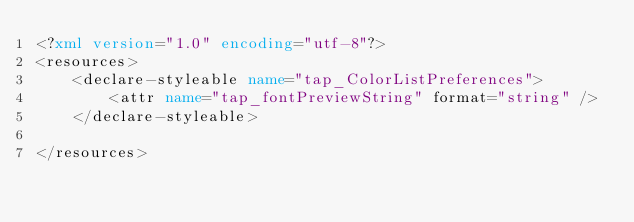<code> <loc_0><loc_0><loc_500><loc_500><_XML_><?xml version="1.0" encoding="utf-8"?>
<resources>
    <declare-styleable name="tap_ColorListPreferences">
        <attr name="tap_fontPreviewString" format="string" />
    </declare-styleable>

</resources></code> 